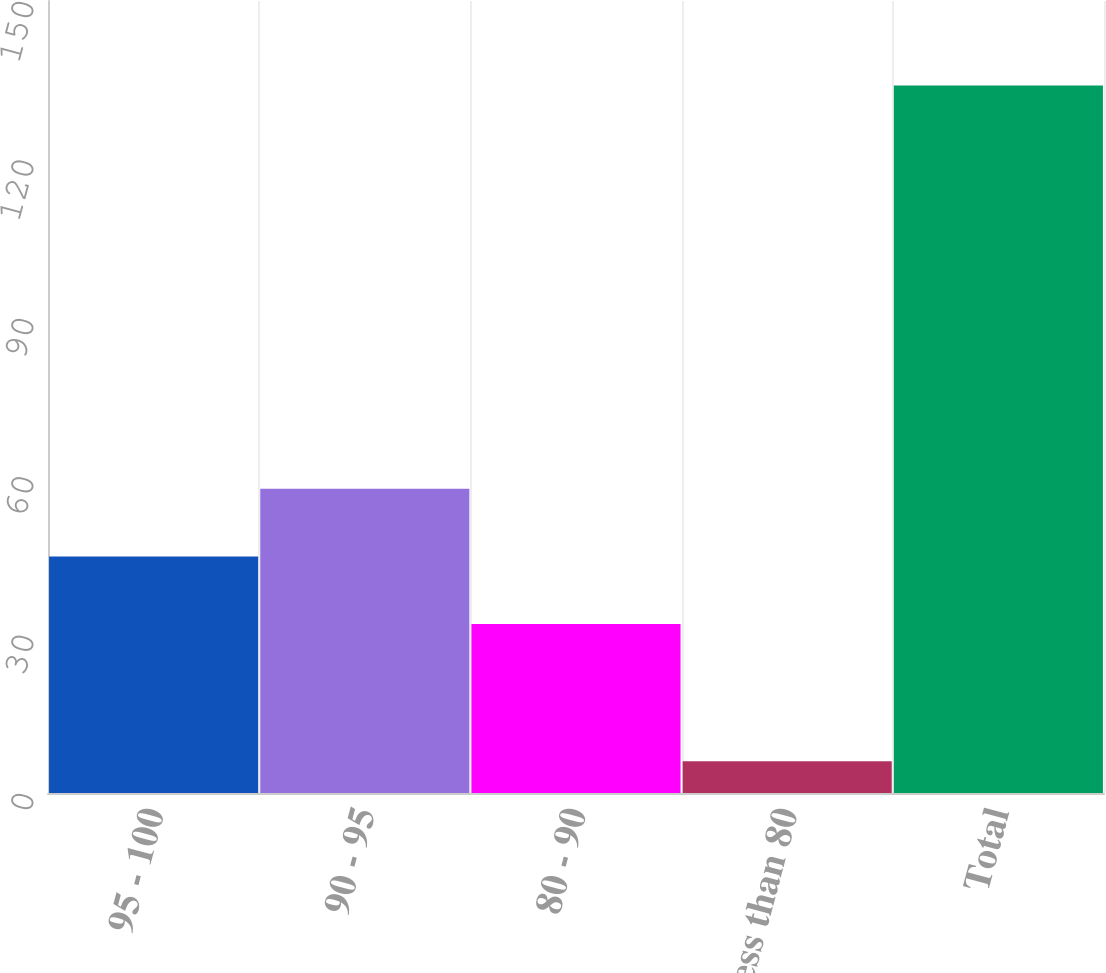Convert chart. <chart><loc_0><loc_0><loc_500><loc_500><bar_chart><fcel>95 - 100<fcel>90 - 95<fcel>80 - 90<fcel>Less than 80<fcel>Total<nl><fcel>44.8<fcel>57.6<fcel>32<fcel>6<fcel>134<nl></chart> 